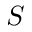Convert formula to latex. <formula><loc_0><loc_0><loc_500><loc_500>S</formula> 